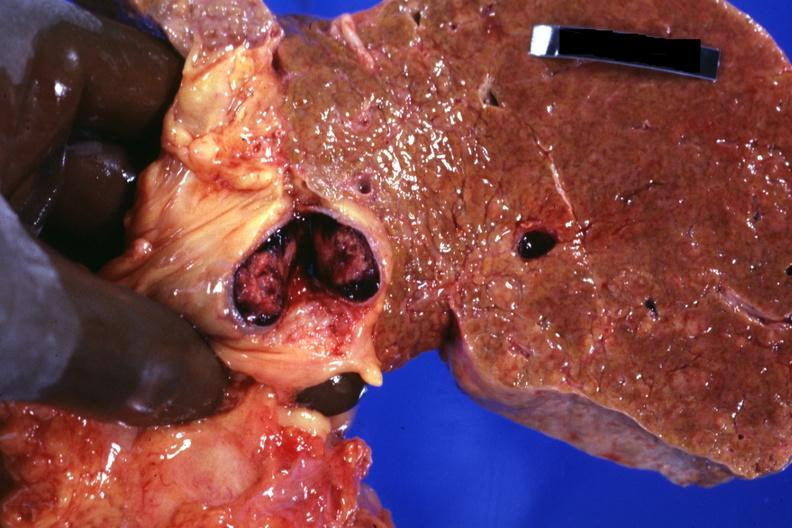s hepatobiliary present?
Answer the question using a single word or phrase. Yes 